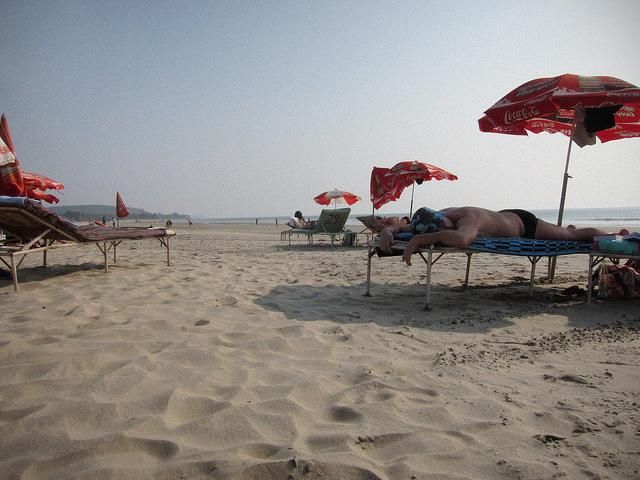The man lying down uses the umbrella for what? shade 